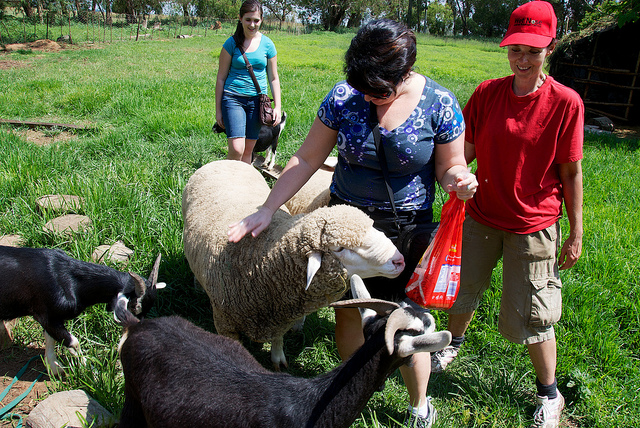What does the background tell you about the environment? The background of the image shows a lush green pasture with tall grass, suggesting a well-maintained and fertile environment. Trees line the horizon, offering some shade and adding to the natural beauty of the scene. This setting indicates an outdoorsy area, possibly part of a larger farm or rural landscape, where animals can roam freely and graze. What can we deduce about the possible activities of the people before this moment captured in the image? Before this moment was captured, it’s likely that the individuals might have spent some time preparing or gathering materials to interact with the animals. They could have been involved in related activities such as feeding, grooming, or simply exploring the farm. The casual and relaxed manner in which they engage with the animals suggests they are familiar with the setting and may have had prior interactions with these or other farm animals. Can you imagine a detailed backstory for the woman in the blue top? The woman in the blue top might be someone who has a deep passion for animals and nature. Perhaps she grew up in a rural area and often visited her grandparents' farm, where she developed a love for sheep and goats. Over the years, she continued to find solace in spending time with animals, often visiting local farms or volunteering at animal sanctuaries. On this particular day, she decided to visit the farm with a couple of friends to de-stress from her hectic city life. Holding a plastic bag full of treats, she eagerly approached the animals, reminiscing about her childhood days spent in the countryside. Her genuine affection for the animals is evident in the gentle way she pets the sheep, rekindling her connection with her past and the peacefulness it brought her. Let's be imaginative: What if the sheep was leading an undercover mission to find lost treasure hidden on the farm? Imagine the sheep is actually the leader of a secret animal society tasked with uncovering hidden treasures on the farm. Every night, when the humans leave, the sheep gathers its troop, consisting of clever goats and agile lambs. They use a map concealed beneath a grassy knoll, marked with ancient symbols only they understand. By following hidden paths and deciphering clues encoded in the patterns of the stars, they inch closer to the long-lost treasure buried deep within the farmgrounds. Perhaps it's an old chest filled with golden artifacts, or maybe it's a stash of rare heirloom seeds that could bring joy to the farm’s caretakers, enhancing the bond between the animals and the humans forever. Envision a scenario in which the scene of the image fits into a larger event happening at the farm. This image could be a part of a larger event like a community farm day, where local residents are invited to visit and interact with the farm animals. Throughout the day, various activities such as animal feeding, guided tours, and educational workshops on sustainable farming practices take place. Families and children could be seen walking through the fields, learning about the different farm animals and their roles in the ecosystem. The farm might also sell homemade products like fresh cheese, honey, and baked goods, showcasing the farm's sustainable practices. As the day progresses, visitors gather for a picnic, enjoying the fresh farm air and the serene atmosphere. Describe a more casual and shorter interaction scene involving these animals and people at the farm. In a more casual scene, the individuals might simply be taking a leisurely afternoon stroll in the pasture. They stop occasionally to pet the friendly animals and enjoy the peaceful environment. The woman with the plastic bag might offer small treats to the animals, and everyone shares light-hearted conversation and laughter, basking in the simple joys of a sunny day on the farm. 